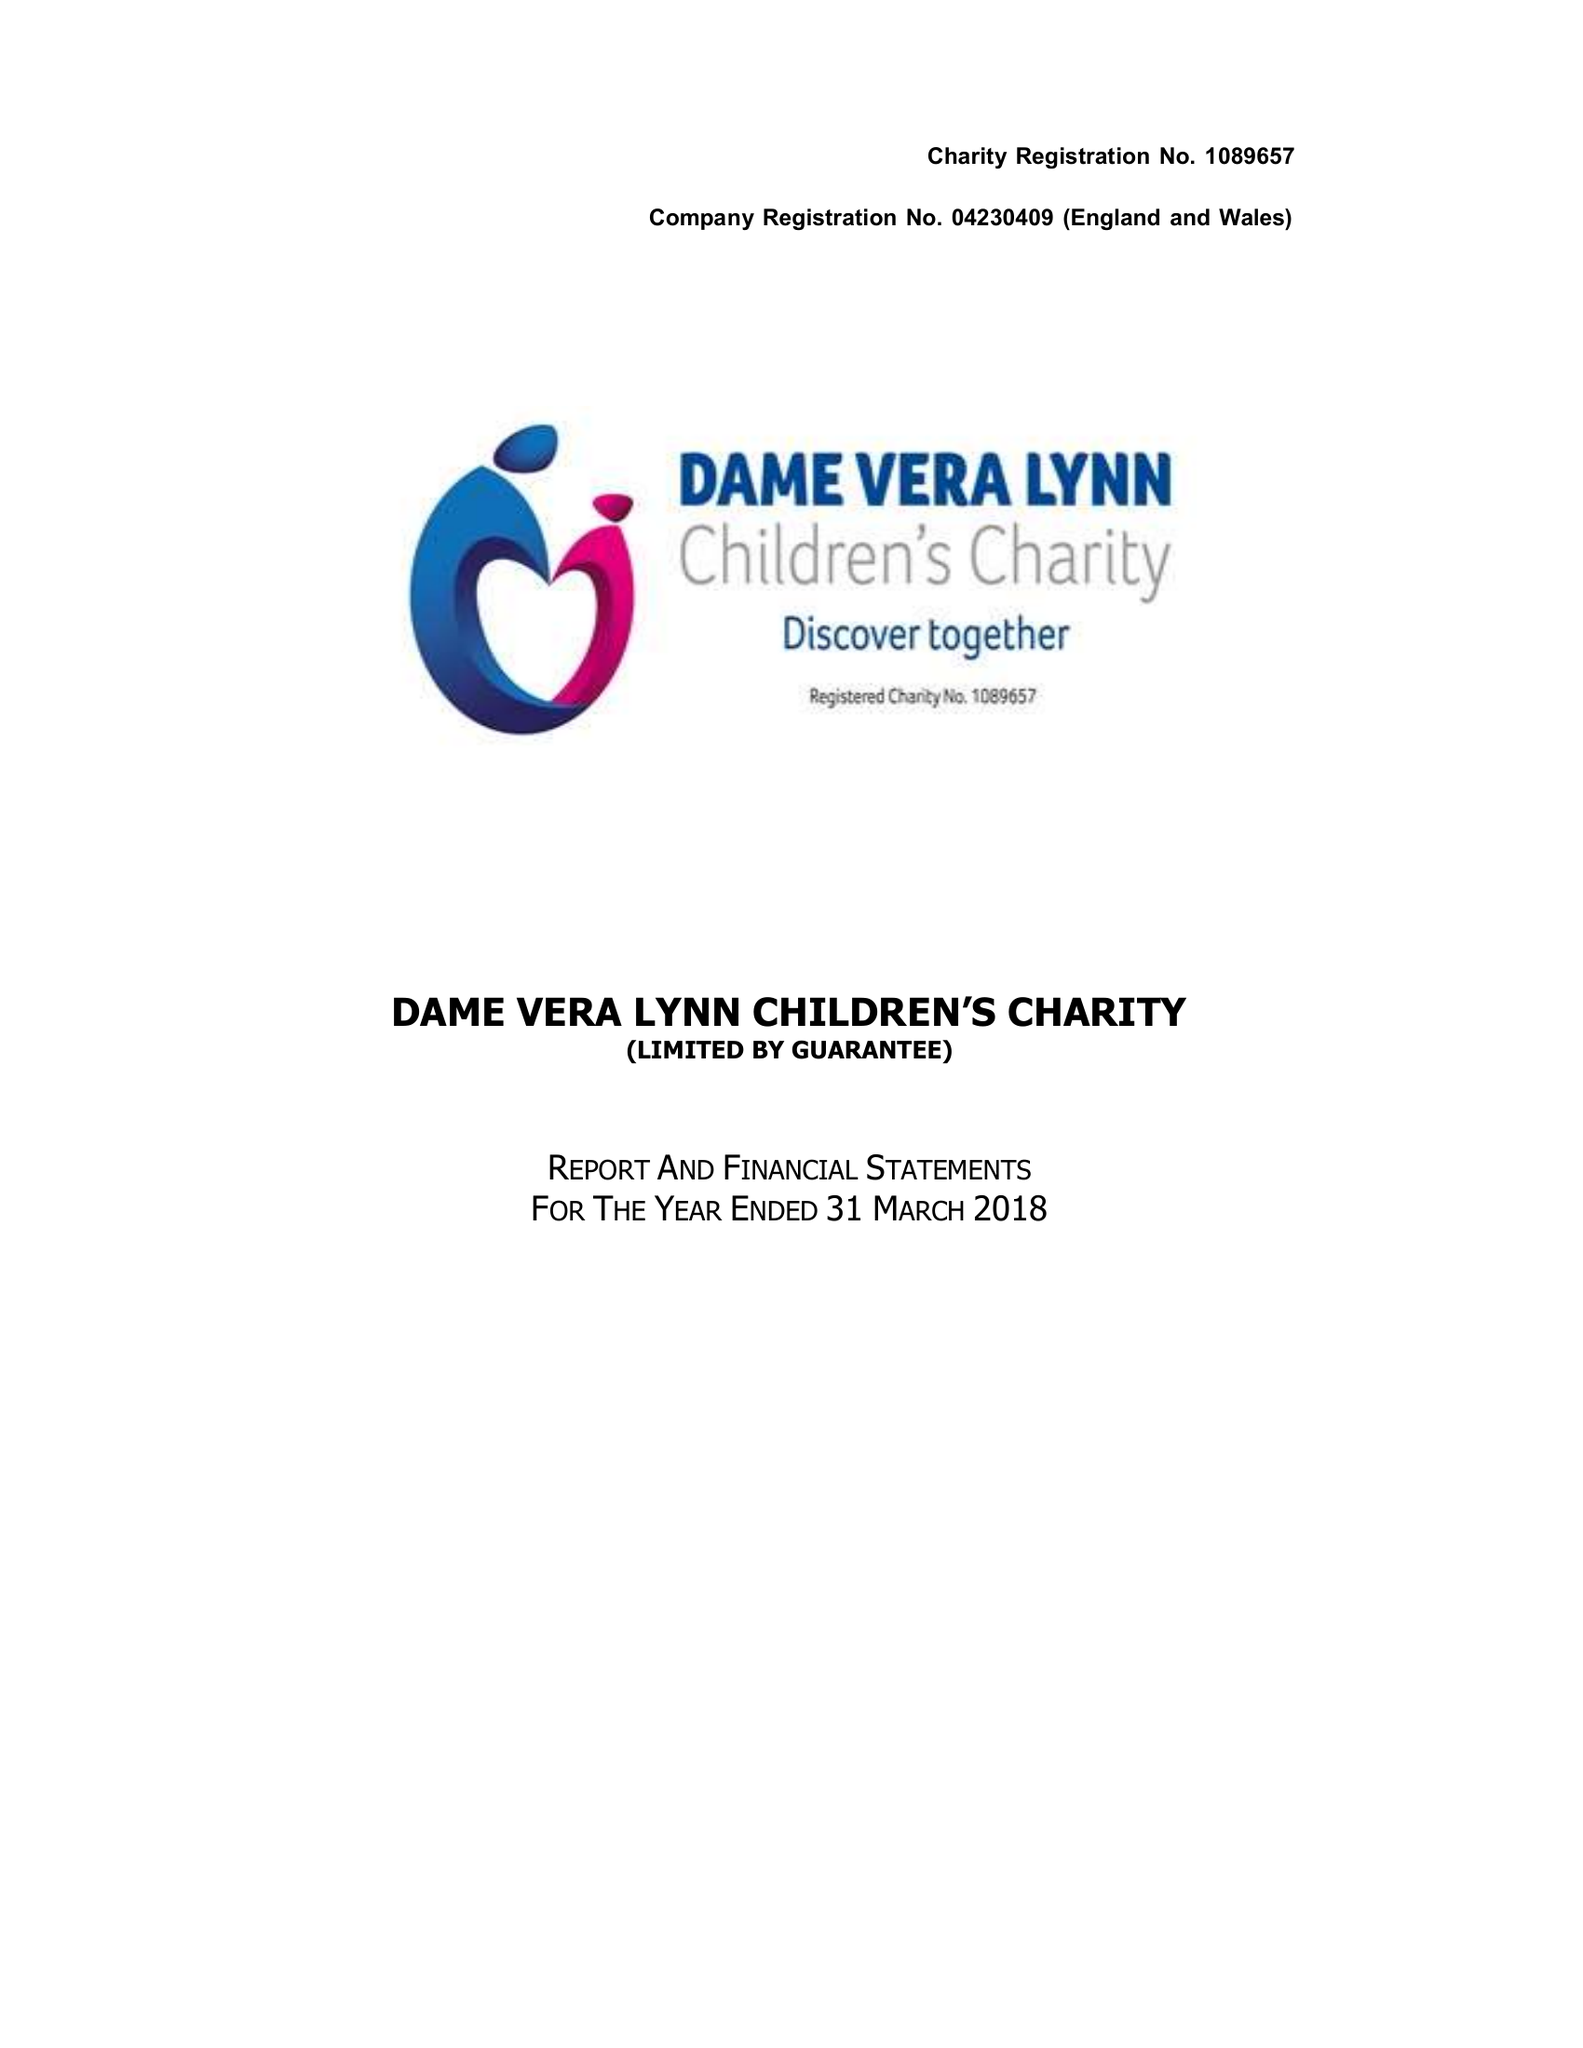What is the value for the address__street_line?
Answer the question using a single word or phrase. STAPLEFIELD ROAD 